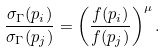Convert formula to latex. <formula><loc_0><loc_0><loc_500><loc_500>\frac { \sigma _ { \Gamma } ( p _ { i } ) } { \sigma _ { \Gamma } ( p _ { j } ) } = \left ( \frac { f ( p _ { i } ) } { f ( p _ { j } ) } \right ) ^ { \mu } .</formula> 